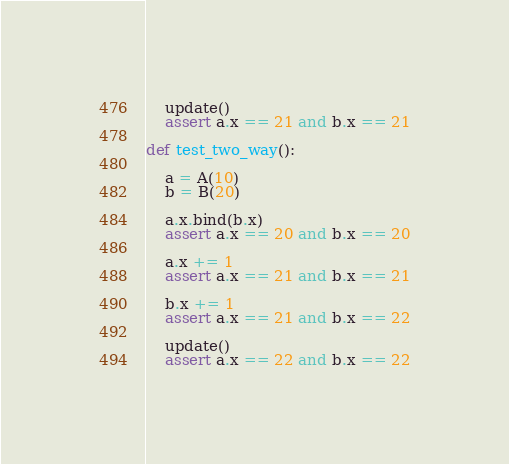<code> <loc_0><loc_0><loc_500><loc_500><_Python_>    update()
    assert a.x == 21 and b.x == 21

def test_two_way():

    a = A(10)
    b = B(20)

    a.x.bind(b.x)
    assert a.x == 20 and b.x == 20

    a.x += 1
    assert a.x == 21 and b.x == 21

    b.x += 1
    assert a.x == 21 and b.x == 22

    update()
    assert a.x == 22 and b.x == 22
</code> 